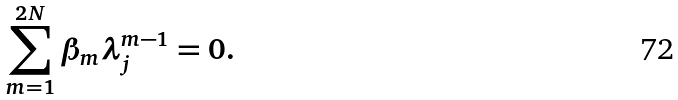Convert formula to latex. <formula><loc_0><loc_0><loc_500><loc_500>\sum _ { m = 1 } ^ { 2 N } \beta _ { m } \lambda _ { j } ^ { m - 1 } = 0 .</formula> 